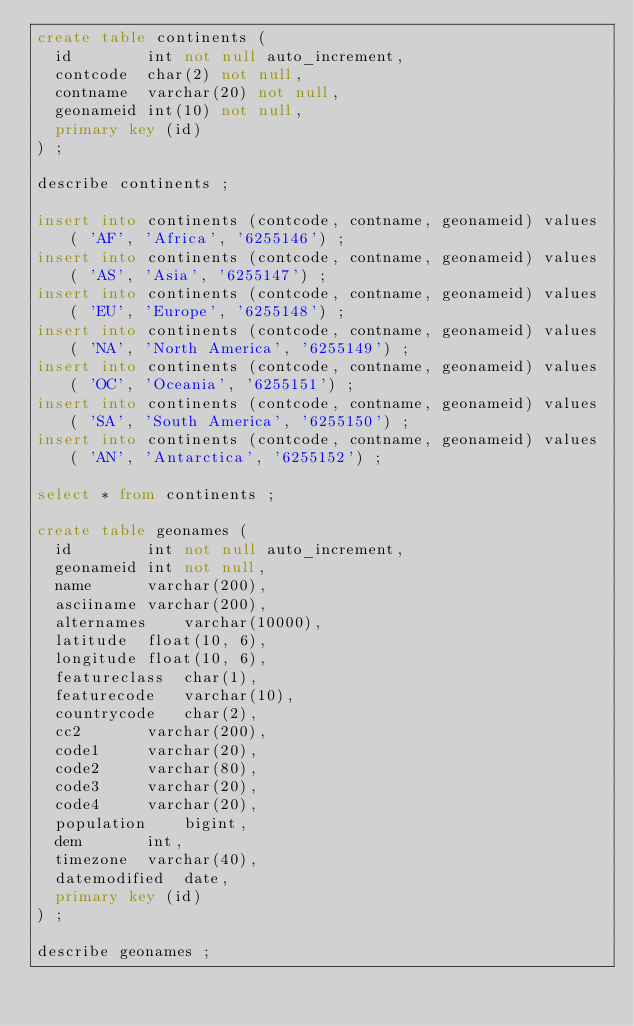<code> <loc_0><loc_0><loc_500><loc_500><_SQL_>create table continents (
  id		int not null auto_increment,
  contcode	char(2) not null,
  contname	varchar(20) not null,
  geonameid	int(10) not null, 
  primary key (id)
) ;

describe continents ;

insert into continents (contcode, contname, geonameid) values ( 'AF', 'Africa', '6255146') ;
insert into continents (contcode, contname, geonameid) values ( 'AS', 'Asia', '6255147') ;
insert into continents (contcode, contname, geonameid) values ( 'EU', 'Europe', '6255148') ;
insert into continents (contcode, contname, geonameid) values ( 'NA', 'North America', '6255149') ;
insert into continents (contcode, contname, geonameid) values ( 'OC', 'Oceania', '6255151') ;
insert into continents (contcode, contname, geonameid) values ( 'SA', 'South America', '6255150') ;
insert into continents (contcode, contname, geonameid) values ( 'AN', 'Antarctica', '6255152') ;

select * from continents ;

create table geonames (
  id		int not null auto_increment,
  geonameid	int not null,
  name		varchar(200),
  asciiname	varchar(200),
  alternames	varchar(10000),
  latitude	float(10, 6),
  longitude	float(10, 6),
  featureclass	char(1),
  featurecode	varchar(10),
  countrycode	char(2),
  cc2		varchar(200),
  code1		varchar(20),
  code2		varchar(80),
  code3		varchar(20),
  code4		varchar(20),
  population	bigint,
  dem		int,
  timezone	varchar(40),
  datemodified	date,
  primary key (id)
) ;

describe geonames ;
</code> 